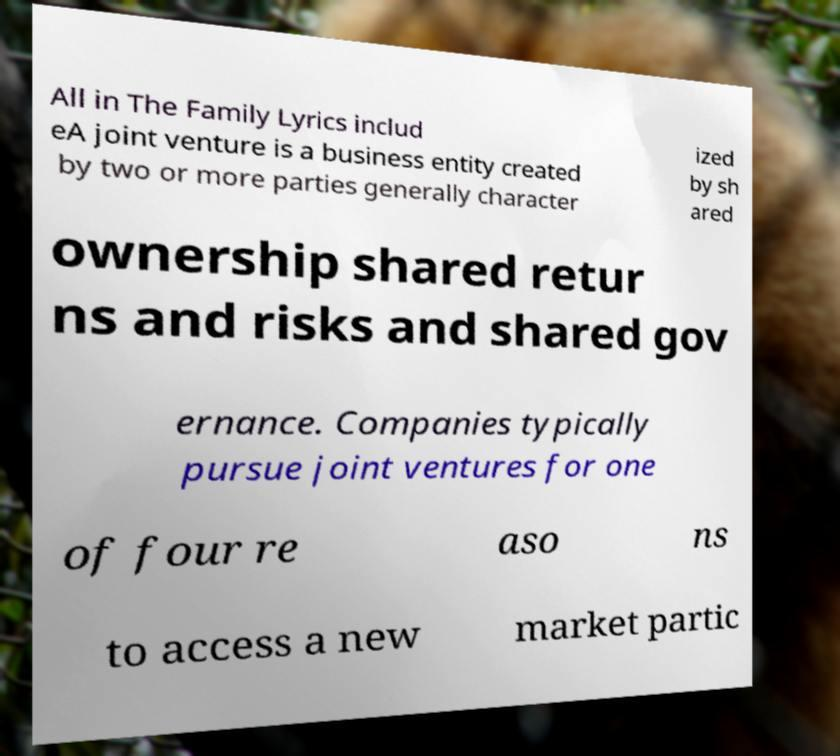Please read and relay the text visible in this image. What does it say? All in The Family Lyrics includ eA joint venture is a business entity created by two or more parties generally character ized by sh ared ownership shared retur ns and risks and shared gov ernance. Companies typically pursue joint ventures for one of four re aso ns to access a new market partic 